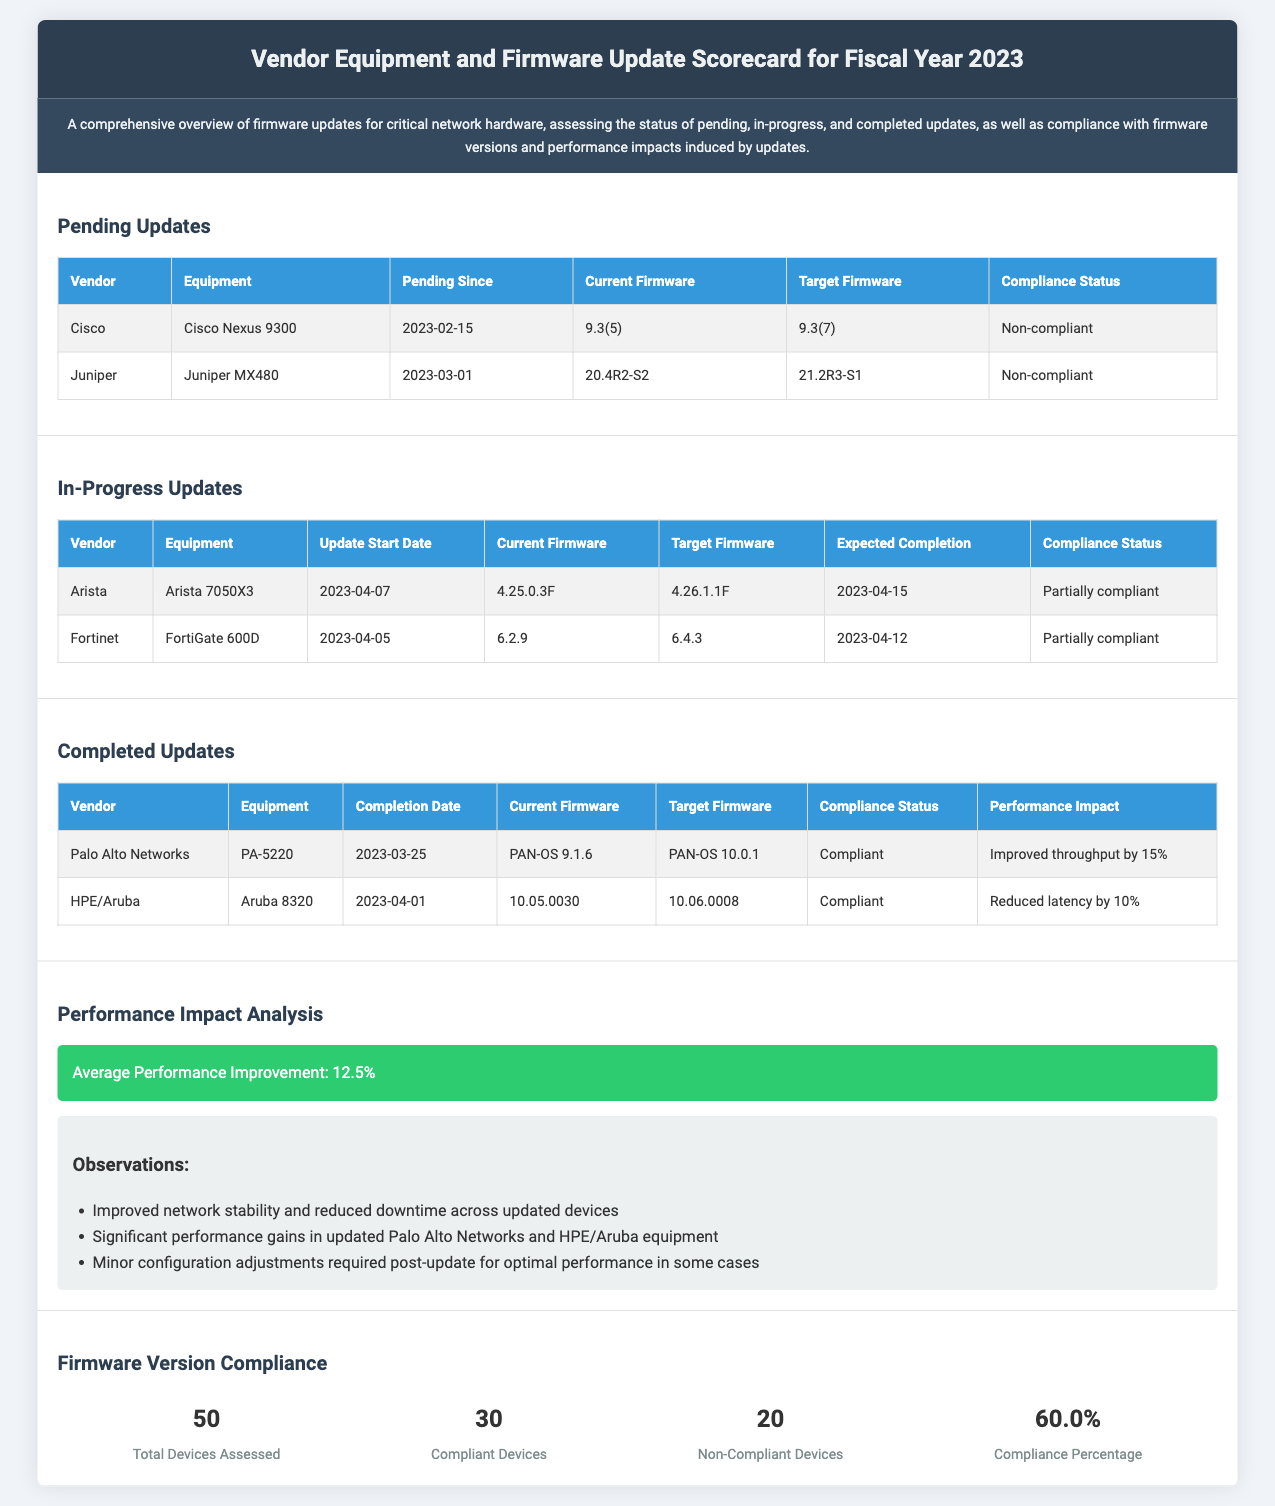What equipment has a pending update since February 15, 2023? The document lists the Cisco Nexus 9300 as having a pending update since February 15, 2023.
Answer: Cisco Nexus 9300 What is the compliance status of the Juniper MX480? The compliance status of the Juniper MX480 is mentioned as "Non-compliant."
Answer: Non-compliant How many compliant devices are there in total? The document states that there are 30 compliant devices assessed.
Answer: 30 What is the expected completion date for the FortiGate 600D update? The expected completion date for the FortiGate 600D update is noted as April 12, 2023.
Answer: April 12, 2023 What average performance improvement is reported in the performance impact analysis? The performance impact analysis mentions an average performance improvement of 12.5%.
Answer: 12.5% Which vendor's equipment showed improved throughput by 15% after the update? The updated equipment from Palo Alto Networks is stated to have improved throughput by 15%.
Answer: Palo Alto Networks What is the total number of devices assessed for firmware version compliance? The total number of devices assessed is noted as 50.
Answer: 50 What firmware version is the Cisco Nexus 9300 currently running? The document indicates that the current firmware version for the Cisco Nexus 9300 is 9.3(5).
Answer: 9.3(5) 